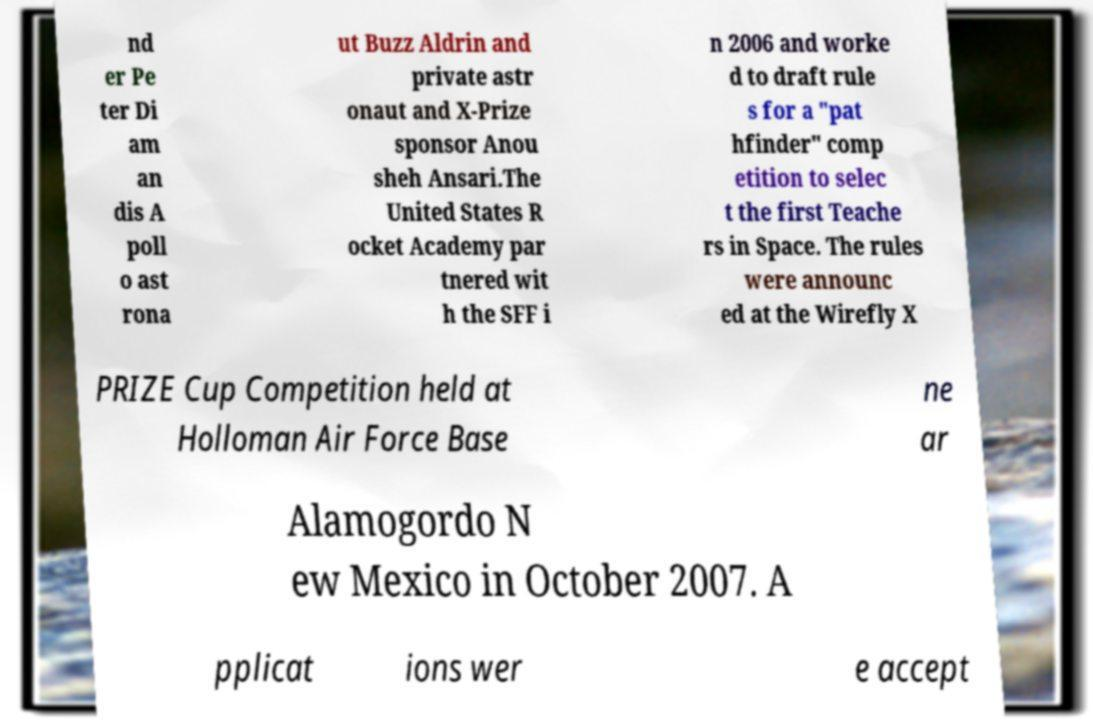Could you extract and type out the text from this image? nd er Pe ter Di am an dis A poll o ast rona ut Buzz Aldrin and private astr onaut and X-Prize sponsor Anou sheh Ansari.The United States R ocket Academy par tnered wit h the SFF i n 2006 and worke d to draft rule s for a "pat hfinder" comp etition to selec t the first Teache rs in Space. The rules were announc ed at the Wirefly X PRIZE Cup Competition held at Holloman Air Force Base ne ar Alamogordo N ew Mexico in October 2007. A pplicat ions wer e accept 